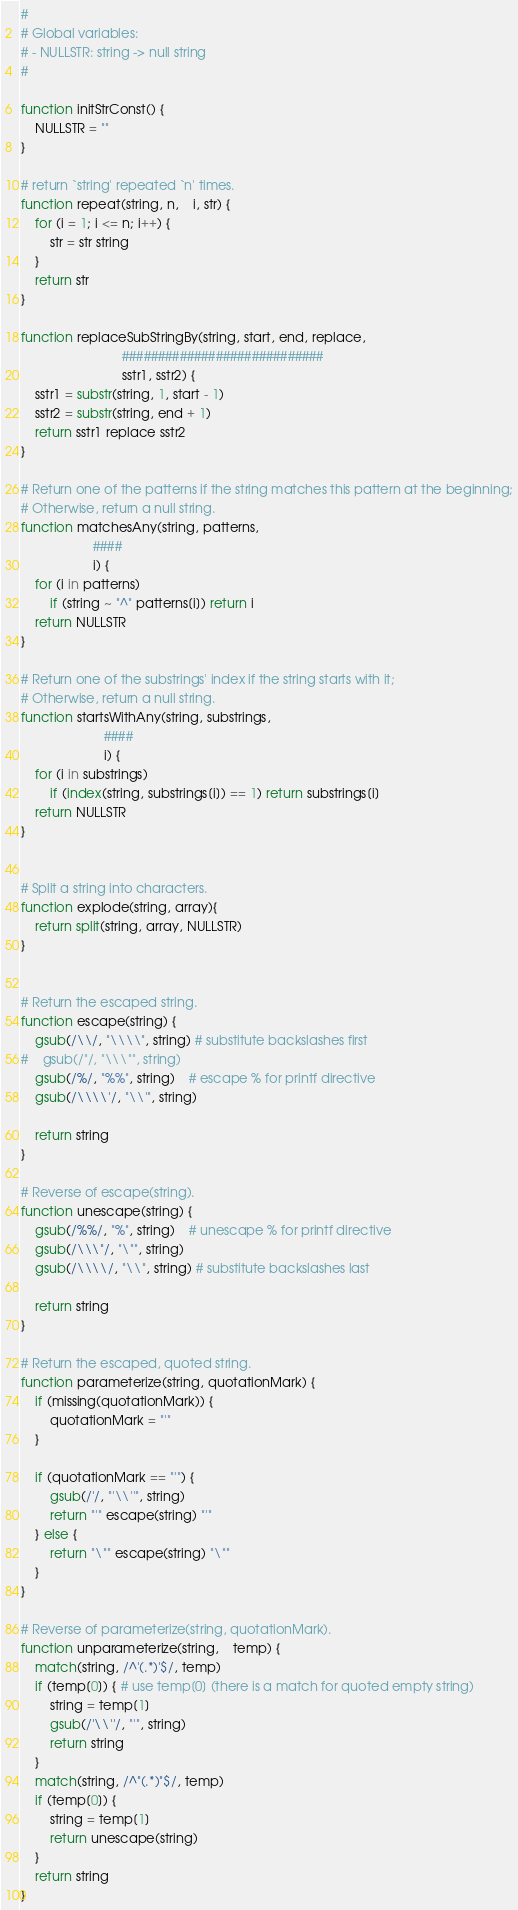<code> <loc_0><loc_0><loc_500><loc_500><_Awk_>
#
# Global variables:
# - NULLSTR: string -> null string
#

function initStrConst() {
    NULLSTR = ""
}

# return `string' repeated `n' times.
function repeat(string, n,    i, str) {
    for (i = 1; i <= n; i++) {
        str = str string
    }
    return str
}

function replaceSubStringBy(string, start, end, replace, 
                            ############################
                            sstr1, sstr2) {
    sstr1 = substr(string, 1, start - 1)
    sstr2 = substr(string, end + 1)
    return sstr1 replace sstr2
}

# Return one of the patterns if the string matches this pattern at the beginning;
# Otherwise, return a null string.
function matchesAny(string, patterns,
                    ####
                    i) {
    for (i in patterns)
        if (string ~ "^" patterns[i]) return i
    return NULLSTR
}

# Return one of the substrings' index if the string starts with it;
# Otherwise, return a null string.
function startsWithAny(string, substrings,
                       ####
                       i) {
    for (i in substrings)
        if (index(string, substrings[i]) == 1) return substrings[i]
    return NULLSTR
}


# Split a string into characters.
function explode(string, array){
    return split(string, array, NULLSTR)
}


# Return the escaped string.
function escape(string) {
    gsub(/\\/, "\\\\", string) # substitute backslashes first
#    gsub(/"/, "\\\"", string)
    gsub(/%/, "%%", string)    # escape % for printf directive
    gsub(/\\\\'/, "\\'", string)

    return string
}

# Reverse of escape(string).
function unescape(string) {
    gsub(/%%/, "%", string)    # unescape % for printf directive
    gsub(/\\\"/, "\"", string)
    gsub(/\\\\/, "\\", string) # substitute backslashes last

    return string
}

# Return the escaped, quoted string.
function parameterize(string, quotationMark) {
    if (missing(quotationMark)) {
        quotationMark = "'"
    }

    if (quotationMark == "'") {
        gsub(/'/, "'\\''", string)
        return "'" escape(string) "'"
    } else {
        return "\"" escape(string) "\""
    }
}

# Reverse of parameterize(string, quotationMark).
function unparameterize(string,    temp) {
    match(string, /^'(.*)'$/, temp)
    if (temp[0]) { # use temp[0] (there is a match for quoted empty string)
        string = temp[1]
        gsub(/'\\''/, "'", string)
        return string
    }
    match(string, /^"(.*)"$/, temp)
    if (temp[0]) {
        string = temp[1]
        return unescape(string)
    }
    return string
}
</code> 